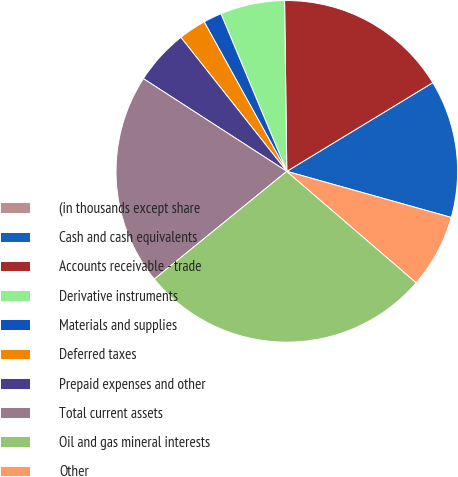Convert chart to OTSL. <chart><loc_0><loc_0><loc_500><loc_500><pie_chart><fcel>(in thousands except share<fcel>Cash and cash equivalents<fcel>Accounts receivable - trade<fcel>Derivative instruments<fcel>Materials and supplies<fcel>Deferred taxes<fcel>Prepaid expenses and other<fcel>Total current assets<fcel>Oil and gas mineral interests<fcel>Other<nl><fcel>0.0%<fcel>13.04%<fcel>16.52%<fcel>6.09%<fcel>1.74%<fcel>2.61%<fcel>5.22%<fcel>20.0%<fcel>27.82%<fcel>6.96%<nl></chart> 